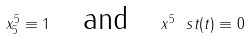Convert formula to latex. <formula><loc_0><loc_0><loc_500><loc_500>x ^ { 5 } _ { 5 } \equiv 1 \quad \text {and} \quad x ^ { 5 } \ s t ( t ) \equiv 0</formula> 